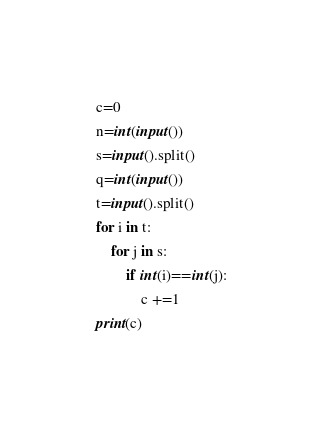Convert code to text. <code><loc_0><loc_0><loc_500><loc_500><_Python_>c=0
n=int(input())
s=input().split()
q=int(input())
t=input().split()
for i in t:
	for j in s:
		if int(i)==int(j):
			c +=1
print(c)
</code> 